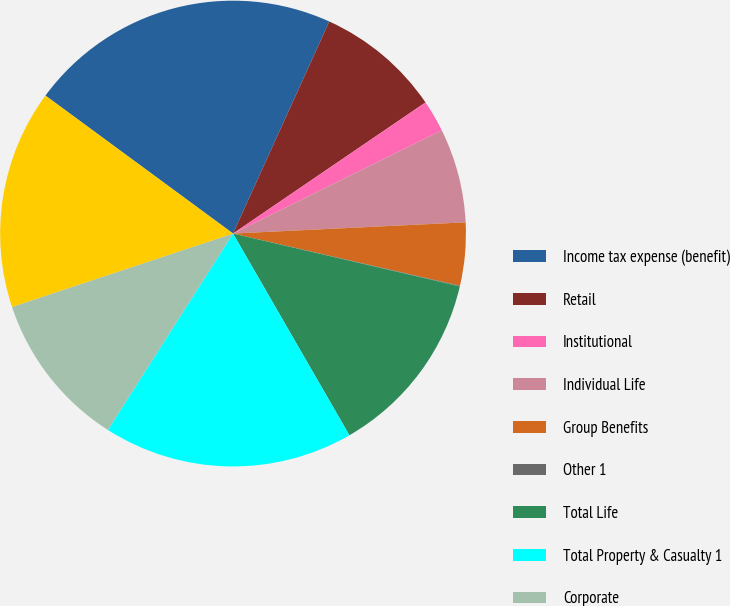<chart> <loc_0><loc_0><loc_500><loc_500><pie_chart><fcel>Income tax expense (benefit)<fcel>Retail<fcel>Institutional<fcel>Individual Life<fcel>Group Benefits<fcel>Other 1<fcel>Total Life<fcel>Total Property & Casualty 1<fcel>Corporate<fcel>Total income tax expense<nl><fcel>21.69%<fcel>8.7%<fcel>2.21%<fcel>6.54%<fcel>4.37%<fcel>0.04%<fcel>13.03%<fcel>17.36%<fcel>10.87%<fcel>15.19%<nl></chart> 